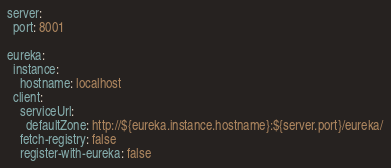Convert code to text. <code><loc_0><loc_0><loc_500><loc_500><_YAML_>server:
  port: 8001

eureka:
  instance:
    hostname: localhost
  client:
    serviceUrl:
      defaultZone: http://${eureka.instance.hostname}:${server.port}/eureka/
    fetch-registry: false
    register-with-eureka: false</code> 